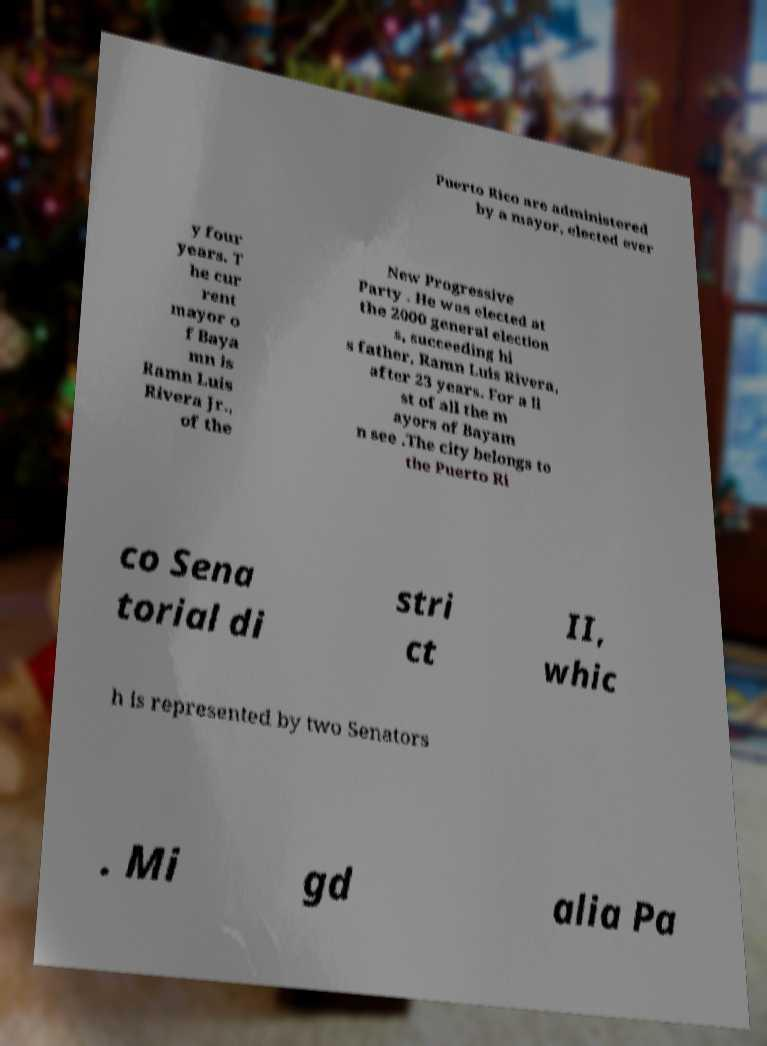Can you accurately transcribe the text from the provided image for me? Puerto Rico are administered by a mayor, elected ever y four years. T he cur rent mayor o f Baya mn is Ramn Luis Rivera Jr., of the New Progressive Party . He was elected at the 2000 general election s, succeeding hi s father, Ramn Luis Rivera, after 23 years. For a li st of all the m ayors of Bayam n see .The city belongs to the Puerto Ri co Sena torial di stri ct II, whic h is represented by two Senators . Mi gd alia Pa 